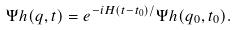<formula> <loc_0><loc_0><loc_500><loc_500>\Psi h ( q , t ) = e ^ { - i H ( t - t _ { 0 } ) / } \Psi h ( q _ { 0 } , t _ { 0 } ) .</formula> 